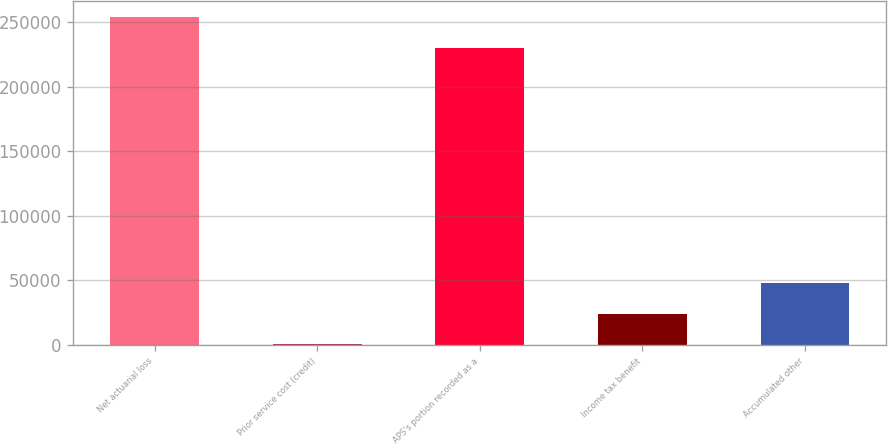<chart> <loc_0><loc_0><loc_500><loc_500><bar_chart><fcel>Net actuarial loss<fcel>Prior service cost (credit)<fcel>APS's portion recorded as a<fcel>Income tax benefit<fcel>Accumulated other<nl><fcel>253859<fcel>475<fcel>230020<fcel>24313.7<fcel>48152.4<nl></chart> 